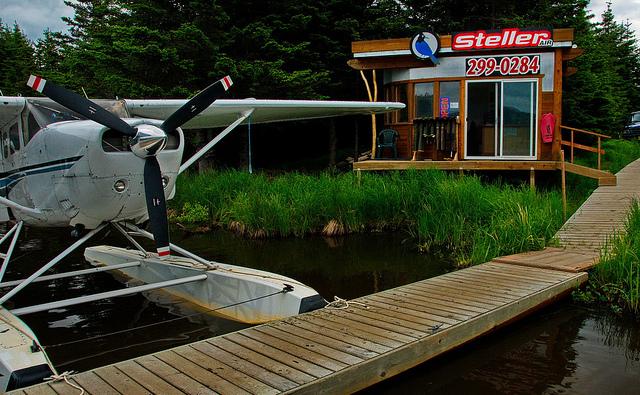What is missing from the phone number?
Keep it brief. Area code. What company is this?
Short answer required. Stellar. What can the plane land on?
Keep it brief. Water. 